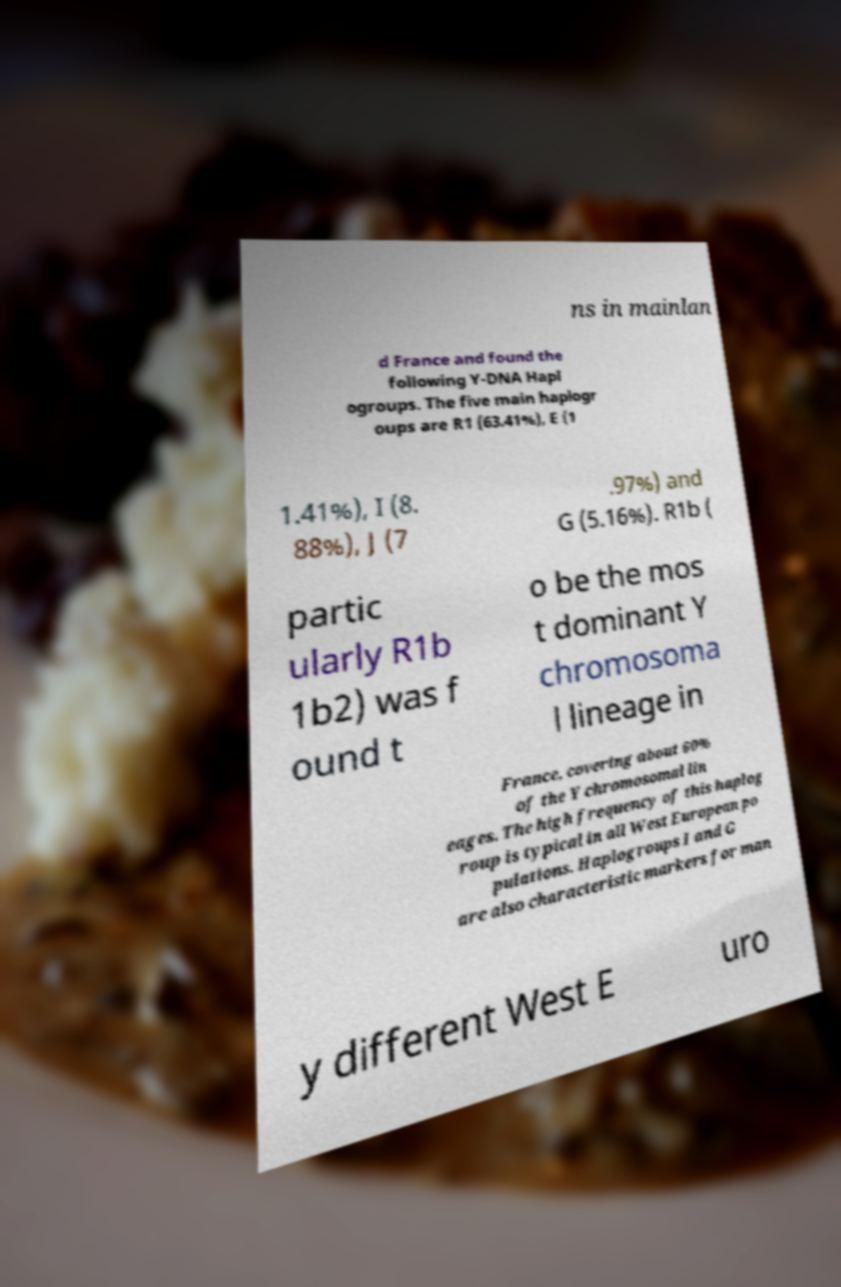Can you read and provide the text displayed in the image?This photo seems to have some interesting text. Can you extract and type it out for me? ns in mainlan d France and found the following Y-DNA Hapl ogroups. The five main haplogr oups are R1 (63.41%), E (1 1.41%), I (8. 88%), J (7 .97%) and G (5.16%). R1b ( partic ularly R1b 1b2) was f ound t o be the mos t dominant Y chromosoma l lineage in France, covering about 60% of the Y chromosomal lin eages. The high frequency of this haplog roup is typical in all West European po pulations. Haplogroups I and G are also characteristic markers for man y different West E uro 